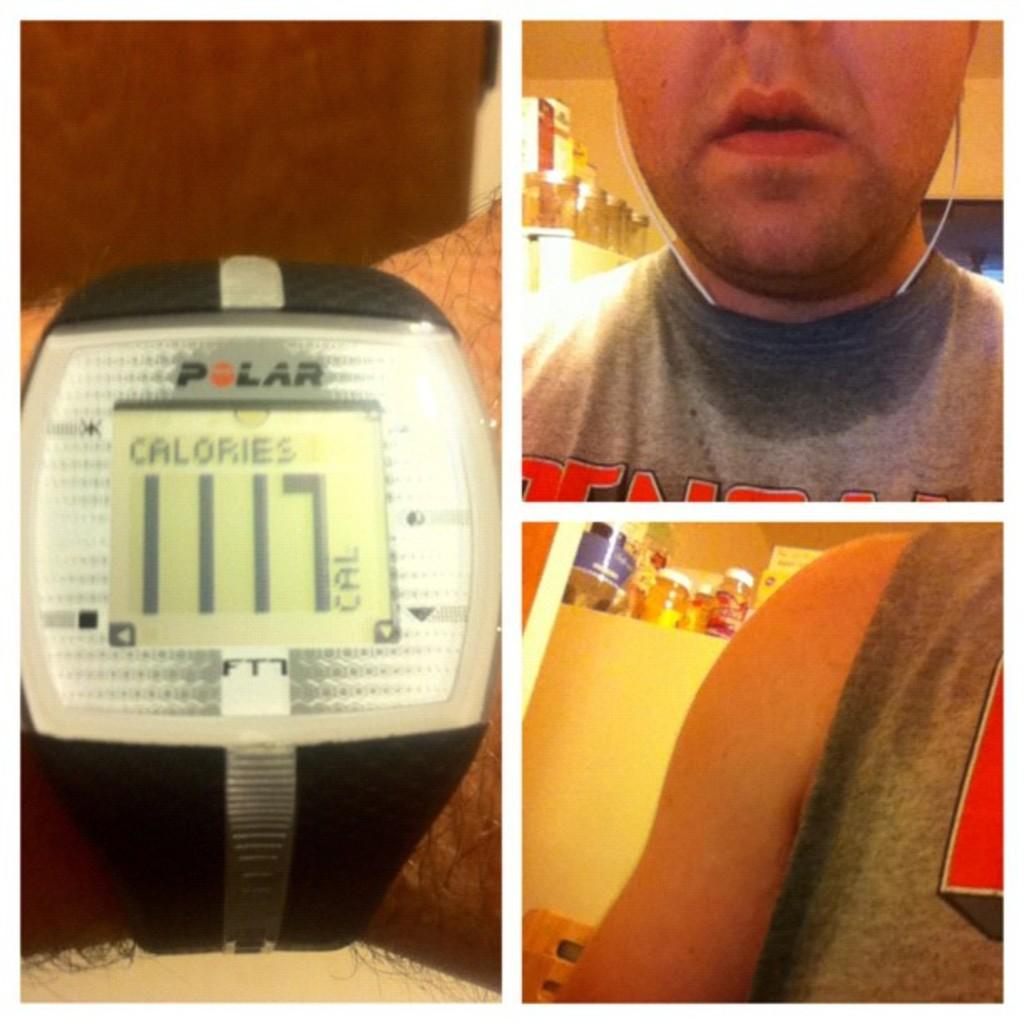How many calories are shown?
Ensure brevity in your answer.  1117. What is the brand of watch?
Provide a short and direct response. Polar. 